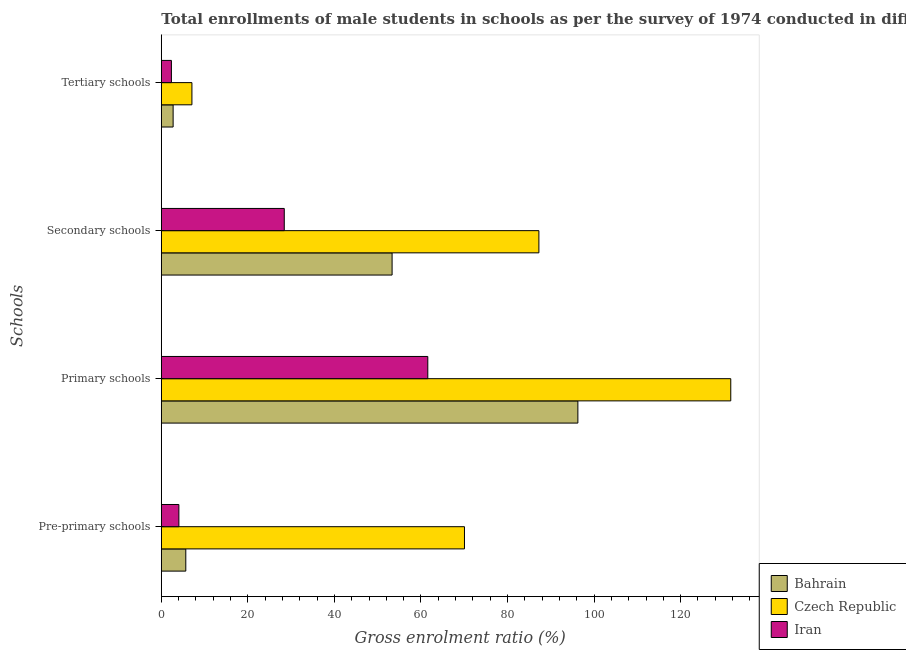How many bars are there on the 2nd tick from the bottom?
Offer a very short reply. 3. What is the label of the 1st group of bars from the top?
Make the answer very short. Tertiary schools. What is the gross enrolment ratio(male) in secondary schools in Bahrain?
Your answer should be compact. 53.33. Across all countries, what is the maximum gross enrolment ratio(male) in primary schools?
Give a very brief answer. 131.59. Across all countries, what is the minimum gross enrolment ratio(male) in secondary schools?
Offer a terse response. 28.41. In which country was the gross enrolment ratio(male) in secondary schools maximum?
Offer a terse response. Czech Republic. In which country was the gross enrolment ratio(male) in primary schools minimum?
Your response must be concise. Iran. What is the total gross enrolment ratio(male) in secondary schools in the graph?
Keep it short and to the point. 168.99. What is the difference between the gross enrolment ratio(male) in pre-primary schools in Bahrain and that in Iran?
Your answer should be compact. 1.6. What is the difference between the gross enrolment ratio(male) in secondary schools in Iran and the gross enrolment ratio(male) in primary schools in Czech Republic?
Offer a very short reply. -103.18. What is the average gross enrolment ratio(male) in secondary schools per country?
Your answer should be compact. 56.33. What is the difference between the gross enrolment ratio(male) in tertiary schools and gross enrolment ratio(male) in pre-primary schools in Iran?
Keep it short and to the point. -1.72. What is the ratio of the gross enrolment ratio(male) in primary schools in Iran to that in Bahrain?
Your response must be concise. 0.64. Is the gross enrolment ratio(male) in tertiary schools in Bahrain less than that in Iran?
Your answer should be compact. No. Is the difference between the gross enrolment ratio(male) in primary schools in Bahrain and Iran greater than the difference between the gross enrolment ratio(male) in pre-primary schools in Bahrain and Iran?
Your answer should be very brief. Yes. What is the difference between the highest and the second highest gross enrolment ratio(male) in primary schools?
Provide a short and direct response. 35.33. What is the difference between the highest and the lowest gross enrolment ratio(male) in primary schools?
Ensure brevity in your answer.  70.01. What does the 1st bar from the top in Primary schools represents?
Offer a terse response. Iran. What does the 3rd bar from the bottom in Secondary schools represents?
Give a very brief answer. Iran. Is it the case that in every country, the sum of the gross enrolment ratio(male) in pre-primary schools and gross enrolment ratio(male) in primary schools is greater than the gross enrolment ratio(male) in secondary schools?
Offer a very short reply. Yes. Are all the bars in the graph horizontal?
Keep it short and to the point. Yes. Are the values on the major ticks of X-axis written in scientific E-notation?
Your answer should be compact. No. Does the graph contain any zero values?
Provide a succinct answer. No. Where does the legend appear in the graph?
Keep it short and to the point. Bottom right. How are the legend labels stacked?
Make the answer very short. Vertical. What is the title of the graph?
Give a very brief answer. Total enrollments of male students in schools as per the survey of 1974 conducted in different countries. What is the label or title of the X-axis?
Make the answer very short. Gross enrolment ratio (%). What is the label or title of the Y-axis?
Your response must be concise. Schools. What is the Gross enrolment ratio (%) of Bahrain in Pre-primary schools?
Provide a short and direct response. 5.66. What is the Gross enrolment ratio (%) of Czech Republic in Pre-primary schools?
Provide a succinct answer. 70.05. What is the Gross enrolment ratio (%) of Iran in Pre-primary schools?
Your response must be concise. 4.06. What is the Gross enrolment ratio (%) of Bahrain in Primary schools?
Make the answer very short. 96.26. What is the Gross enrolment ratio (%) in Czech Republic in Primary schools?
Your response must be concise. 131.59. What is the Gross enrolment ratio (%) in Iran in Primary schools?
Ensure brevity in your answer.  61.58. What is the Gross enrolment ratio (%) of Bahrain in Secondary schools?
Your answer should be very brief. 53.33. What is the Gross enrolment ratio (%) in Czech Republic in Secondary schools?
Your answer should be very brief. 87.25. What is the Gross enrolment ratio (%) in Iran in Secondary schools?
Offer a very short reply. 28.41. What is the Gross enrolment ratio (%) of Bahrain in Tertiary schools?
Your response must be concise. 2.73. What is the Gross enrolment ratio (%) in Czech Republic in Tertiary schools?
Your response must be concise. 7.07. What is the Gross enrolment ratio (%) in Iran in Tertiary schools?
Provide a short and direct response. 2.33. Across all Schools, what is the maximum Gross enrolment ratio (%) in Bahrain?
Provide a succinct answer. 96.26. Across all Schools, what is the maximum Gross enrolment ratio (%) of Czech Republic?
Offer a very short reply. 131.59. Across all Schools, what is the maximum Gross enrolment ratio (%) in Iran?
Ensure brevity in your answer.  61.58. Across all Schools, what is the minimum Gross enrolment ratio (%) in Bahrain?
Your answer should be very brief. 2.73. Across all Schools, what is the minimum Gross enrolment ratio (%) of Czech Republic?
Provide a succinct answer. 7.07. Across all Schools, what is the minimum Gross enrolment ratio (%) in Iran?
Offer a very short reply. 2.33. What is the total Gross enrolment ratio (%) of Bahrain in the graph?
Provide a short and direct response. 157.98. What is the total Gross enrolment ratio (%) in Czech Republic in the graph?
Give a very brief answer. 295.97. What is the total Gross enrolment ratio (%) in Iran in the graph?
Your response must be concise. 96.38. What is the difference between the Gross enrolment ratio (%) of Bahrain in Pre-primary schools and that in Primary schools?
Provide a succinct answer. -90.6. What is the difference between the Gross enrolment ratio (%) of Czech Republic in Pre-primary schools and that in Primary schools?
Your answer should be compact. -61.54. What is the difference between the Gross enrolment ratio (%) in Iran in Pre-primary schools and that in Primary schools?
Give a very brief answer. -57.52. What is the difference between the Gross enrolment ratio (%) of Bahrain in Pre-primary schools and that in Secondary schools?
Ensure brevity in your answer.  -47.67. What is the difference between the Gross enrolment ratio (%) in Czech Republic in Pre-primary schools and that in Secondary schools?
Provide a succinct answer. -17.2. What is the difference between the Gross enrolment ratio (%) of Iran in Pre-primary schools and that in Secondary schools?
Offer a very short reply. -24.36. What is the difference between the Gross enrolment ratio (%) of Bahrain in Pre-primary schools and that in Tertiary schools?
Your response must be concise. 2.93. What is the difference between the Gross enrolment ratio (%) in Czech Republic in Pre-primary schools and that in Tertiary schools?
Provide a short and direct response. 62.98. What is the difference between the Gross enrolment ratio (%) in Iran in Pre-primary schools and that in Tertiary schools?
Your response must be concise. 1.72. What is the difference between the Gross enrolment ratio (%) of Bahrain in Primary schools and that in Secondary schools?
Make the answer very short. 42.93. What is the difference between the Gross enrolment ratio (%) in Czech Republic in Primary schools and that in Secondary schools?
Make the answer very short. 44.34. What is the difference between the Gross enrolment ratio (%) in Iran in Primary schools and that in Secondary schools?
Your answer should be very brief. 33.17. What is the difference between the Gross enrolment ratio (%) of Bahrain in Primary schools and that in Tertiary schools?
Give a very brief answer. 93.53. What is the difference between the Gross enrolment ratio (%) of Czech Republic in Primary schools and that in Tertiary schools?
Make the answer very short. 124.52. What is the difference between the Gross enrolment ratio (%) of Iran in Primary schools and that in Tertiary schools?
Your answer should be very brief. 59.24. What is the difference between the Gross enrolment ratio (%) of Bahrain in Secondary schools and that in Tertiary schools?
Give a very brief answer. 50.6. What is the difference between the Gross enrolment ratio (%) of Czech Republic in Secondary schools and that in Tertiary schools?
Your answer should be very brief. 80.18. What is the difference between the Gross enrolment ratio (%) in Iran in Secondary schools and that in Tertiary schools?
Offer a very short reply. 26.08. What is the difference between the Gross enrolment ratio (%) of Bahrain in Pre-primary schools and the Gross enrolment ratio (%) of Czech Republic in Primary schools?
Your answer should be compact. -125.93. What is the difference between the Gross enrolment ratio (%) of Bahrain in Pre-primary schools and the Gross enrolment ratio (%) of Iran in Primary schools?
Offer a very short reply. -55.92. What is the difference between the Gross enrolment ratio (%) in Czech Republic in Pre-primary schools and the Gross enrolment ratio (%) in Iran in Primary schools?
Give a very brief answer. 8.47. What is the difference between the Gross enrolment ratio (%) of Bahrain in Pre-primary schools and the Gross enrolment ratio (%) of Czech Republic in Secondary schools?
Make the answer very short. -81.59. What is the difference between the Gross enrolment ratio (%) of Bahrain in Pre-primary schools and the Gross enrolment ratio (%) of Iran in Secondary schools?
Give a very brief answer. -22.75. What is the difference between the Gross enrolment ratio (%) of Czech Republic in Pre-primary schools and the Gross enrolment ratio (%) of Iran in Secondary schools?
Offer a terse response. 41.64. What is the difference between the Gross enrolment ratio (%) of Bahrain in Pre-primary schools and the Gross enrolment ratio (%) of Czech Republic in Tertiary schools?
Keep it short and to the point. -1.41. What is the difference between the Gross enrolment ratio (%) in Bahrain in Pre-primary schools and the Gross enrolment ratio (%) in Iran in Tertiary schools?
Provide a short and direct response. 3.33. What is the difference between the Gross enrolment ratio (%) of Czech Republic in Pre-primary schools and the Gross enrolment ratio (%) of Iran in Tertiary schools?
Give a very brief answer. 67.72. What is the difference between the Gross enrolment ratio (%) of Bahrain in Primary schools and the Gross enrolment ratio (%) of Czech Republic in Secondary schools?
Provide a short and direct response. 9.01. What is the difference between the Gross enrolment ratio (%) of Bahrain in Primary schools and the Gross enrolment ratio (%) of Iran in Secondary schools?
Your answer should be compact. 67.85. What is the difference between the Gross enrolment ratio (%) in Czech Republic in Primary schools and the Gross enrolment ratio (%) in Iran in Secondary schools?
Your response must be concise. 103.18. What is the difference between the Gross enrolment ratio (%) of Bahrain in Primary schools and the Gross enrolment ratio (%) of Czech Republic in Tertiary schools?
Your answer should be compact. 89.19. What is the difference between the Gross enrolment ratio (%) in Bahrain in Primary schools and the Gross enrolment ratio (%) in Iran in Tertiary schools?
Offer a terse response. 93.93. What is the difference between the Gross enrolment ratio (%) in Czech Republic in Primary schools and the Gross enrolment ratio (%) in Iran in Tertiary schools?
Keep it short and to the point. 129.26. What is the difference between the Gross enrolment ratio (%) of Bahrain in Secondary schools and the Gross enrolment ratio (%) of Czech Republic in Tertiary schools?
Your response must be concise. 46.26. What is the difference between the Gross enrolment ratio (%) of Bahrain in Secondary schools and the Gross enrolment ratio (%) of Iran in Tertiary schools?
Keep it short and to the point. 51. What is the difference between the Gross enrolment ratio (%) in Czech Republic in Secondary schools and the Gross enrolment ratio (%) in Iran in Tertiary schools?
Make the answer very short. 84.92. What is the average Gross enrolment ratio (%) of Bahrain per Schools?
Provide a succinct answer. 39.49. What is the average Gross enrolment ratio (%) in Czech Republic per Schools?
Your answer should be compact. 73.99. What is the average Gross enrolment ratio (%) in Iran per Schools?
Offer a very short reply. 24.09. What is the difference between the Gross enrolment ratio (%) in Bahrain and Gross enrolment ratio (%) in Czech Republic in Pre-primary schools?
Your response must be concise. -64.39. What is the difference between the Gross enrolment ratio (%) of Bahrain and Gross enrolment ratio (%) of Iran in Pre-primary schools?
Make the answer very short. 1.6. What is the difference between the Gross enrolment ratio (%) of Czech Republic and Gross enrolment ratio (%) of Iran in Pre-primary schools?
Make the answer very short. 66. What is the difference between the Gross enrolment ratio (%) in Bahrain and Gross enrolment ratio (%) in Czech Republic in Primary schools?
Ensure brevity in your answer.  -35.33. What is the difference between the Gross enrolment ratio (%) of Bahrain and Gross enrolment ratio (%) of Iran in Primary schools?
Your response must be concise. 34.68. What is the difference between the Gross enrolment ratio (%) of Czech Republic and Gross enrolment ratio (%) of Iran in Primary schools?
Your response must be concise. 70.01. What is the difference between the Gross enrolment ratio (%) in Bahrain and Gross enrolment ratio (%) in Czech Republic in Secondary schools?
Your answer should be compact. -33.92. What is the difference between the Gross enrolment ratio (%) of Bahrain and Gross enrolment ratio (%) of Iran in Secondary schools?
Provide a succinct answer. 24.92. What is the difference between the Gross enrolment ratio (%) in Czech Republic and Gross enrolment ratio (%) in Iran in Secondary schools?
Ensure brevity in your answer.  58.84. What is the difference between the Gross enrolment ratio (%) in Bahrain and Gross enrolment ratio (%) in Czech Republic in Tertiary schools?
Offer a very short reply. -4.34. What is the difference between the Gross enrolment ratio (%) in Bahrain and Gross enrolment ratio (%) in Iran in Tertiary schools?
Your answer should be very brief. 0.4. What is the difference between the Gross enrolment ratio (%) of Czech Republic and Gross enrolment ratio (%) of Iran in Tertiary schools?
Offer a terse response. 4.74. What is the ratio of the Gross enrolment ratio (%) in Bahrain in Pre-primary schools to that in Primary schools?
Provide a succinct answer. 0.06. What is the ratio of the Gross enrolment ratio (%) of Czech Republic in Pre-primary schools to that in Primary schools?
Offer a terse response. 0.53. What is the ratio of the Gross enrolment ratio (%) in Iran in Pre-primary schools to that in Primary schools?
Offer a terse response. 0.07. What is the ratio of the Gross enrolment ratio (%) of Bahrain in Pre-primary schools to that in Secondary schools?
Provide a short and direct response. 0.11. What is the ratio of the Gross enrolment ratio (%) in Czech Republic in Pre-primary schools to that in Secondary schools?
Provide a short and direct response. 0.8. What is the ratio of the Gross enrolment ratio (%) in Iran in Pre-primary schools to that in Secondary schools?
Provide a short and direct response. 0.14. What is the ratio of the Gross enrolment ratio (%) of Bahrain in Pre-primary schools to that in Tertiary schools?
Your response must be concise. 2.07. What is the ratio of the Gross enrolment ratio (%) of Czech Republic in Pre-primary schools to that in Tertiary schools?
Give a very brief answer. 9.9. What is the ratio of the Gross enrolment ratio (%) in Iran in Pre-primary schools to that in Tertiary schools?
Ensure brevity in your answer.  1.74. What is the ratio of the Gross enrolment ratio (%) of Bahrain in Primary schools to that in Secondary schools?
Offer a very short reply. 1.8. What is the ratio of the Gross enrolment ratio (%) in Czech Republic in Primary schools to that in Secondary schools?
Make the answer very short. 1.51. What is the ratio of the Gross enrolment ratio (%) in Iran in Primary schools to that in Secondary schools?
Offer a terse response. 2.17. What is the ratio of the Gross enrolment ratio (%) of Bahrain in Primary schools to that in Tertiary schools?
Provide a succinct answer. 35.27. What is the ratio of the Gross enrolment ratio (%) in Czech Republic in Primary schools to that in Tertiary schools?
Keep it short and to the point. 18.6. What is the ratio of the Gross enrolment ratio (%) of Iran in Primary schools to that in Tertiary schools?
Offer a terse response. 26.4. What is the ratio of the Gross enrolment ratio (%) of Bahrain in Secondary schools to that in Tertiary schools?
Provide a succinct answer. 19.54. What is the ratio of the Gross enrolment ratio (%) in Czech Republic in Secondary schools to that in Tertiary schools?
Offer a very short reply. 12.34. What is the ratio of the Gross enrolment ratio (%) of Iran in Secondary schools to that in Tertiary schools?
Provide a short and direct response. 12.18. What is the difference between the highest and the second highest Gross enrolment ratio (%) in Bahrain?
Offer a very short reply. 42.93. What is the difference between the highest and the second highest Gross enrolment ratio (%) of Czech Republic?
Provide a short and direct response. 44.34. What is the difference between the highest and the second highest Gross enrolment ratio (%) in Iran?
Provide a succinct answer. 33.17. What is the difference between the highest and the lowest Gross enrolment ratio (%) of Bahrain?
Your answer should be very brief. 93.53. What is the difference between the highest and the lowest Gross enrolment ratio (%) in Czech Republic?
Your response must be concise. 124.52. What is the difference between the highest and the lowest Gross enrolment ratio (%) in Iran?
Ensure brevity in your answer.  59.24. 